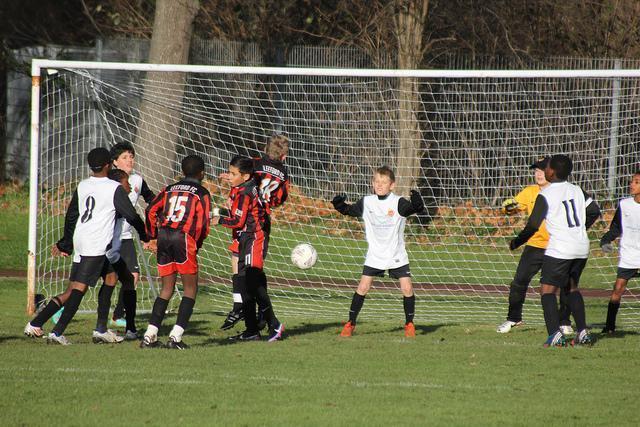Why is one kid wearing yellow?
Indicate the correct response and explain using: 'Answer: answer
Rationale: rationale.'
Options: Umpire, water boy, goalie, referee. Answer: goalie.
Rationale: Goalies for both teams wear a special color to distinguish themselves. 